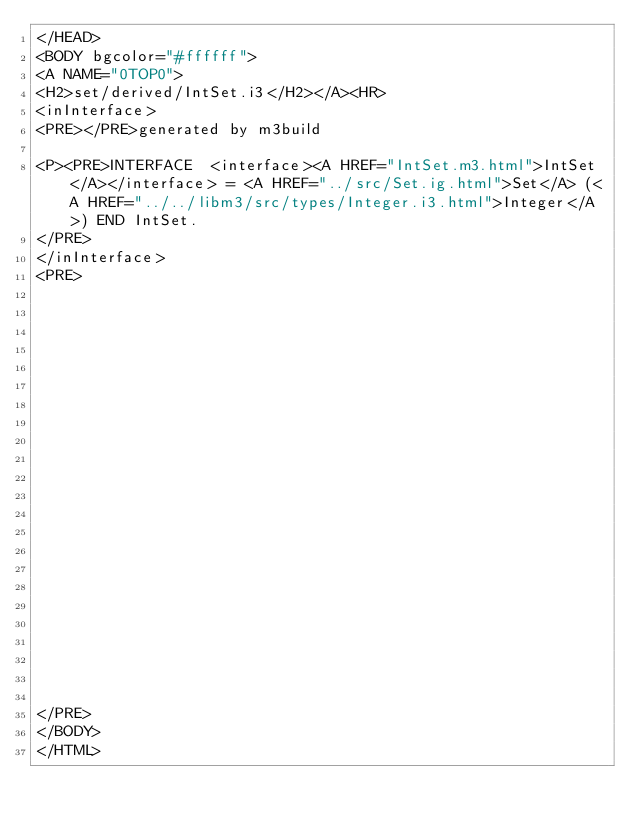Convert code to text. <code><loc_0><loc_0><loc_500><loc_500><_HTML_></HEAD>
<BODY bgcolor="#ffffff">
<A NAME="0TOP0">
<H2>set/derived/IntSet.i3</H2></A><HR>
<inInterface>
<PRE></PRE>generated by m3build

<P><PRE>INTERFACE  <interface><A HREF="IntSet.m3.html">IntSet</A></interface> = <A HREF="../src/Set.ig.html">Set</A> (<A HREF="../../libm3/src/types/Integer.i3.html">Integer</A>) END IntSet.
</PRE>
</inInterface>
<PRE>























</PRE>
</BODY>
</HTML>
</code> 